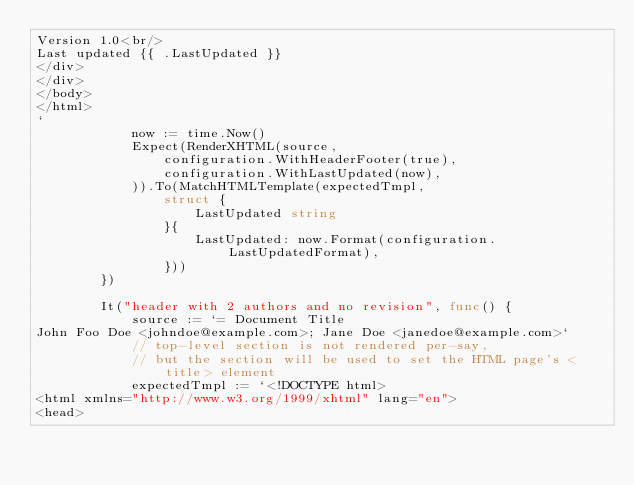Convert code to text. <code><loc_0><loc_0><loc_500><loc_500><_Go_>Version 1.0<br/>
Last updated {{ .LastUpdated }}
</div>
</div>
</body>
</html>
`
			now := time.Now()
			Expect(RenderXHTML(source,
				configuration.WithHeaderFooter(true),
				configuration.WithLastUpdated(now),
			)).To(MatchHTMLTemplate(expectedTmpl,
				struct {
					LastUpdated string
				}{
					LastUpdated: now.Format(configuration.LastUpdatedFormat),
				}))
		})

		It("header with 2 authors and no revision", func() {
			source := `= Document Title
John Foo Doe <johndoe@example.com>; Jane Doe <janedoe@example.com>`
			// top-level section is not rendered per-say,
			// but the section will be used to set the HTML page's <title> element
			expectedTmpl := `<!DOCTYPE html>
<html xmlns="http://www.w3.org/1999/xhtml" lang="en">
<head></code> 